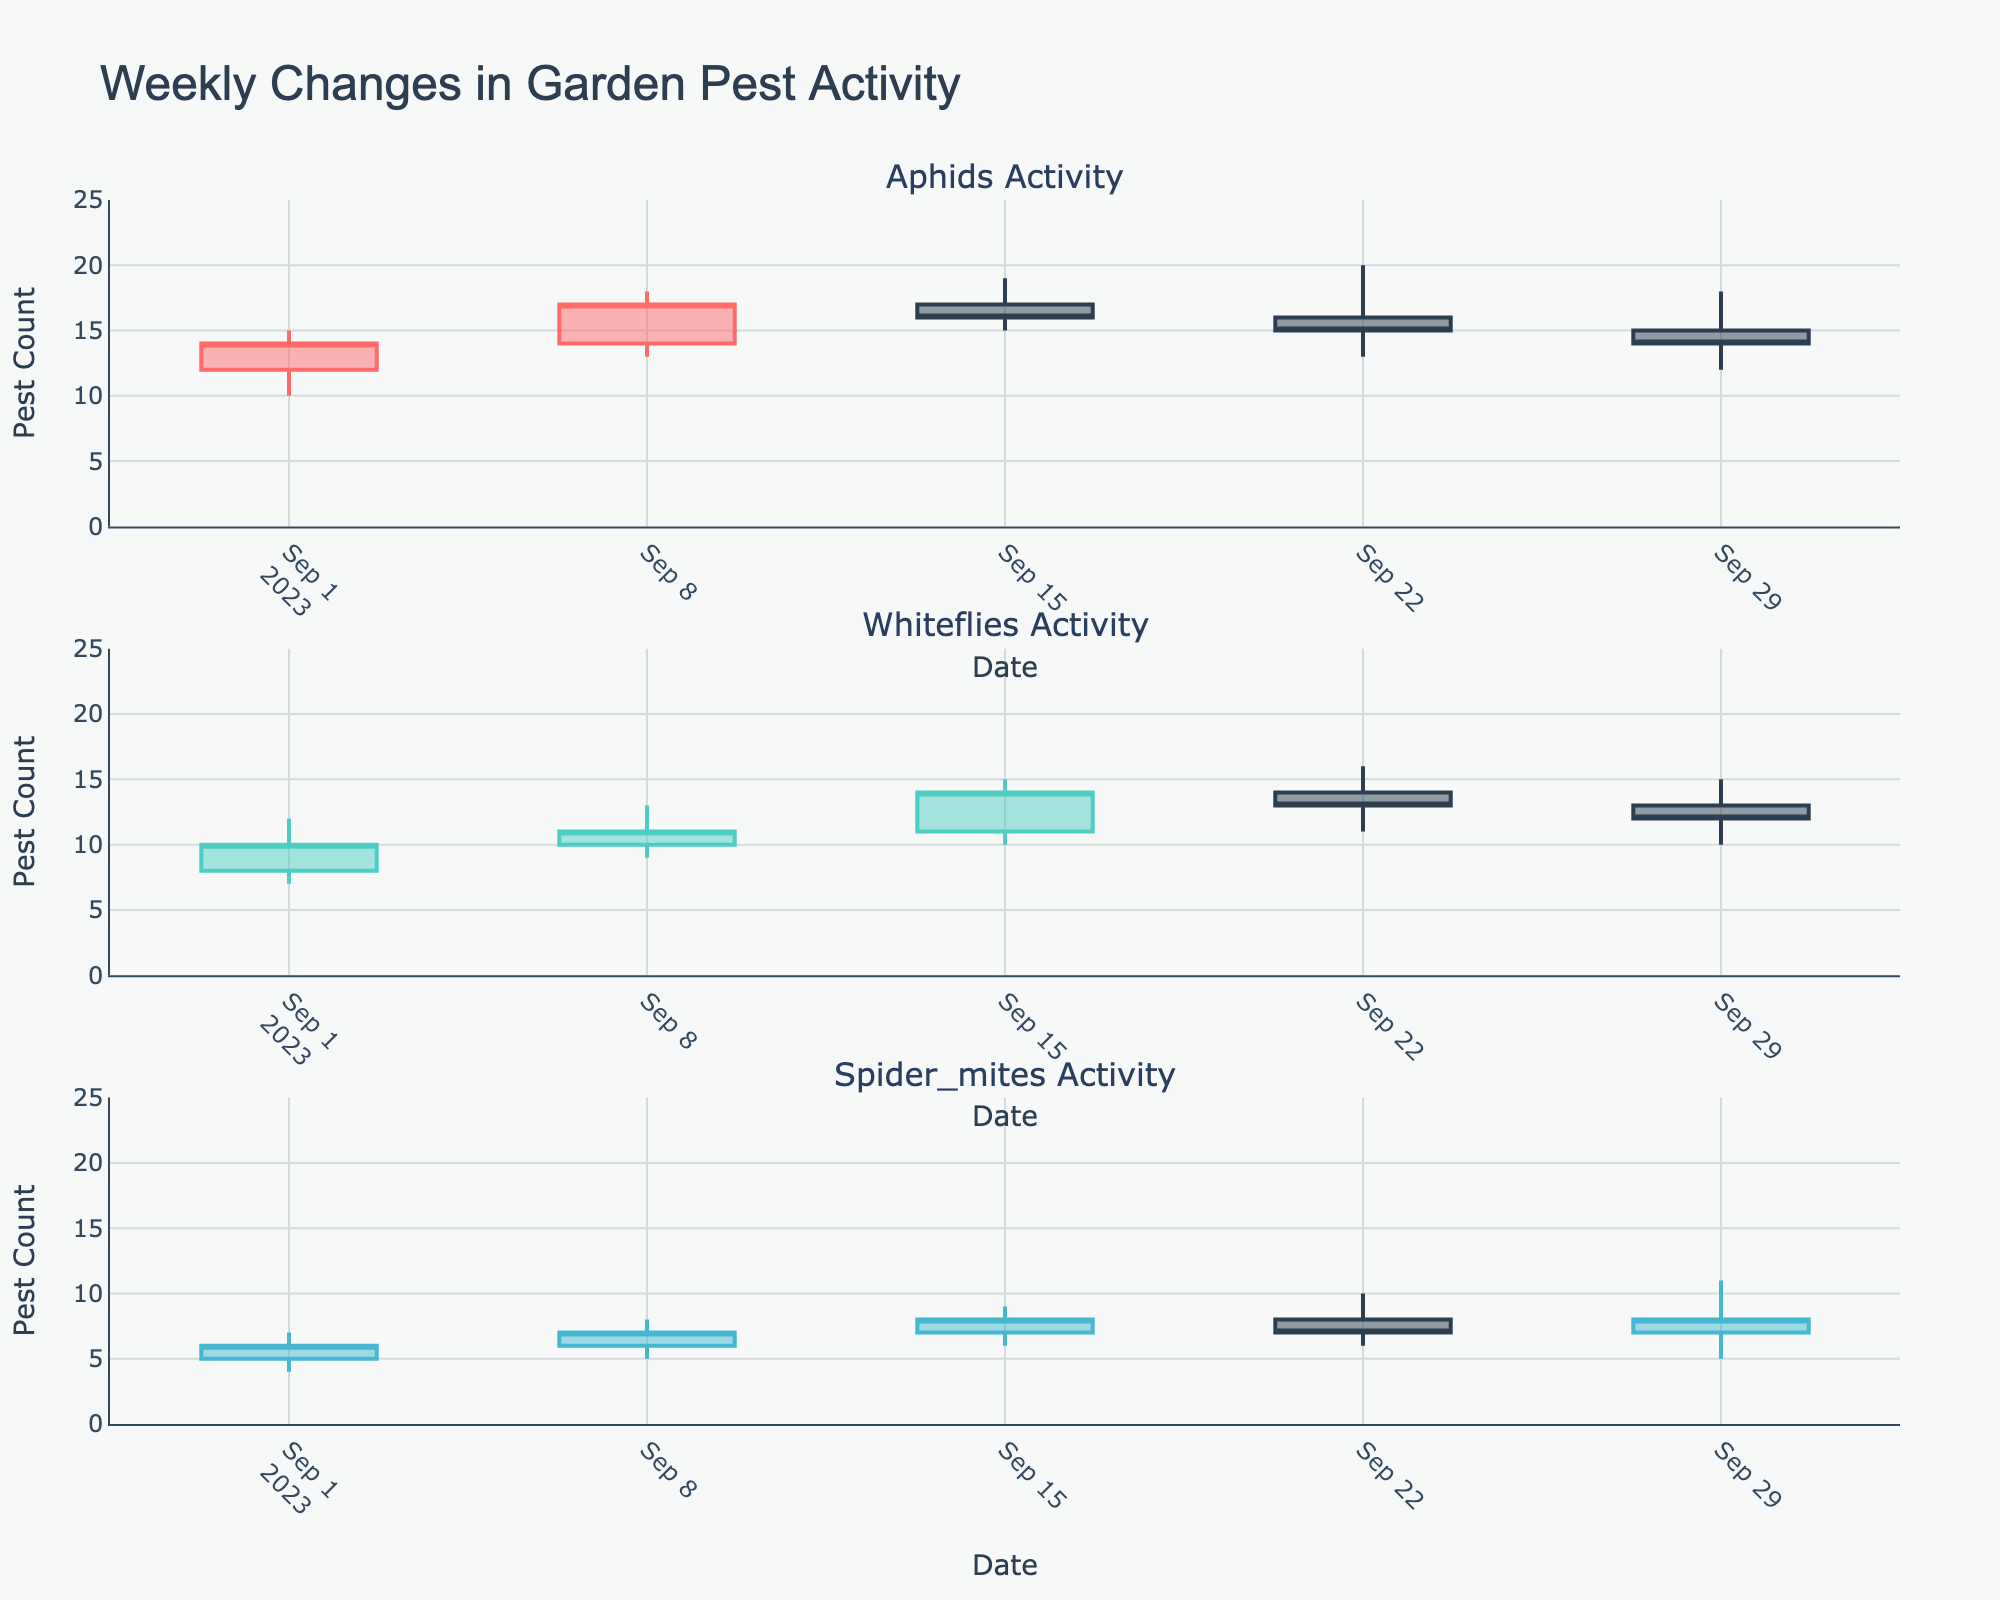Which pest has the highest count during the week of September 8th? To determine the pest with the highest count on September 8th, look at the candlesticks for that date for each pest type. Check the "High" value for each pest to see which one is the highest. Aphids have a high of 18, Whiteflies 13, and Spider mites 8. Therefore, Aphids have the highest count.
Answer: Aphids How many weeks did Aphids show a decrease in the closing count? To determine the number of weeks the closing count of Aphids decreased, compare the close value of each week with the close value of the previous week. The closing values are 14, 17, 16, 15, 14. The count decreased in the weeks ending on September 15th, September 22nd, and September 29th.
Answer: 3 Which pest showed the largest single-week increase in their closing count? To find this, calculate the difference in closing counts between consecutive weeks for each pest. Aphids: (17-14=3), (16-17=-1), (15-16=-1), (14-15=-1). Whiteflies: (11-10=1), (14-11=3), (13-14=-1), (12-13=-1). Spider mites: (7-6=1), (8-7=1), (7-8=-1), (8-7=1). Whiteflies have the largest increase of 3.
Answer: Aphids and Whiteflies (Both 3) For Whiteflies, what is the overall trend in their activity over the month? Examine the closing values for Whiteflies over the weeks: 10, 11, 14, 13, 12. The general trend shows fluctuating values with a slight upwards movement at first and a drop towards the end of the month.
Answer: Fluctuating with no clear trend During the week of September 22nd, which pest had the lowest low value? The pests' low values for September 22nd are: Aphids 13, Whiteflies 11, Spider mites 6. Compare these and the lowest value is 6 for Spider mites.
Answer: Spider mites What is the median closing value for Aphids over the five weeks? To find the median closing value for Aphids, list the closing values: 14, 17, 16, 15, 14. Arrange them in ascending order: 14, 14, 15, 16, 17. The median value is the middle value in this list, which is 15.
Answer: 15 Which pest showed the most consistent closing values (least variation) over the five weeks? To determine consistency, calculate the range (High - Low) for closing values for each pest. Aphids: 17-14=3, 16-17=1, 15-16=1, 14-15=1. Whiteflies: 11-10=1, 14-11=3, 13-14=1, 12-13=1. Spider mites: 7-6=1, 8-7=1, 7-8=1, 8-7=1. Spider mites have the smallest range indicating the most consistency.
Answer: Spider mites 